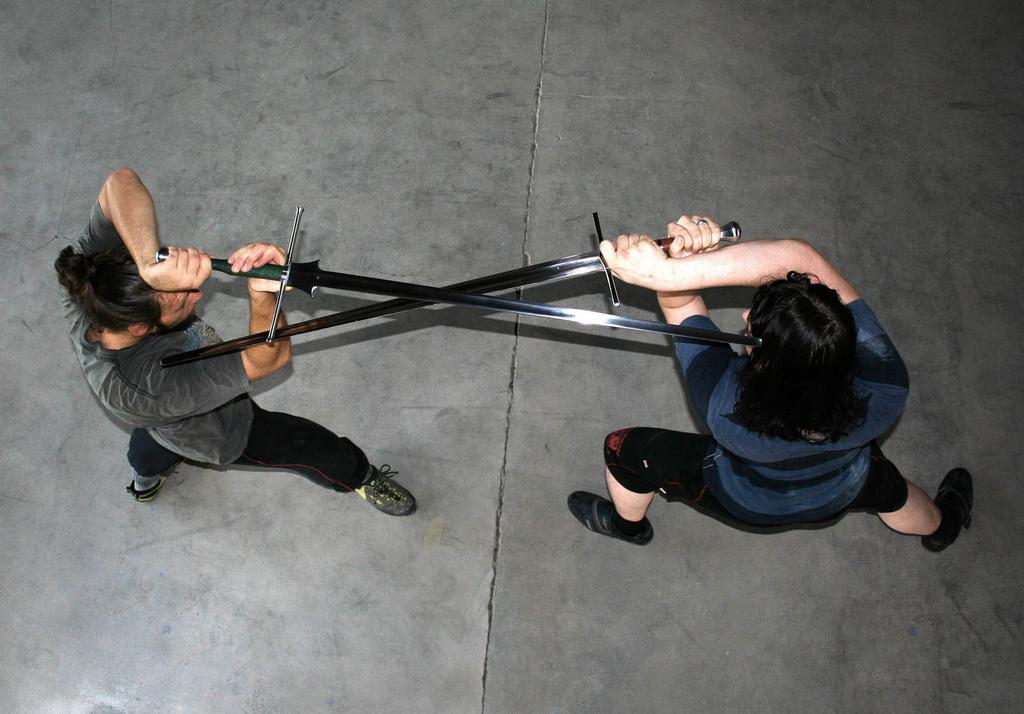How many people are present in the image? There are two people in the image. What are the people doing in the image? The people are standing on a surface and holding swords in their hands. What action are the people performing with their swords? The people are placing the swords towards each other. What type of chain can be seen connecting the swords in the image? There is no chain connecting the swords in the image; the swords are simply being placed towards each other. 